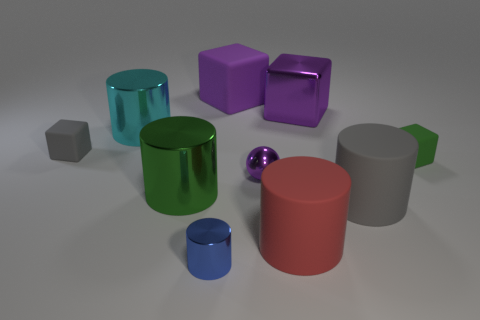Which object in the image has the most reflective surface? The small purple sphere in the image has the most reflective surface, evidenced by the clear reflections of other objects and the environment observed on its surface. 